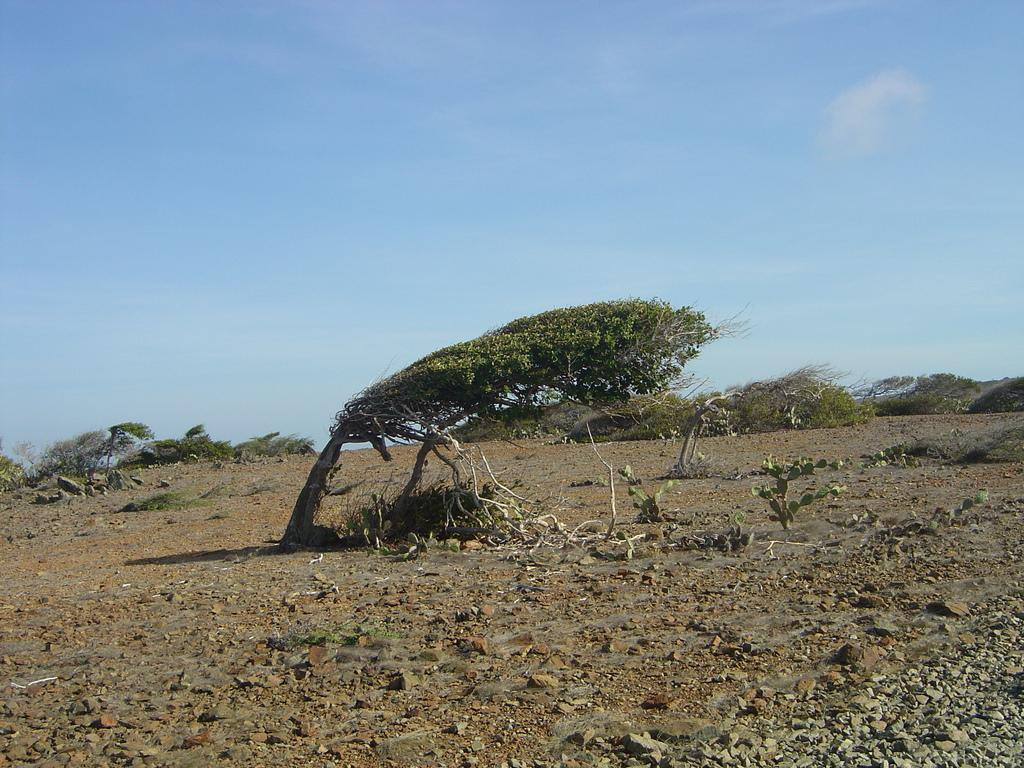What type of vegetation can be seen in the image? There are trees in the image. Where are the trees located? The trees are in an open ground. How many spiders can be seen crawling on the trees in the image? There are no spiders visible in the image; it only shows trees in an open ground. In which direction are the trees leaning in the image? The trees are not leaning in any specific direction in the image; they are standing upright. 